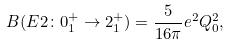Convert formula to latex. <formula><loc_0><loc_0><loc_500><loc_500>B ( E 2 \colon 0 _ { 1 } ^ { + } \rightarrow 2 _ { 1 } ^ { + } ) = \frac { 5 } { 1 6 \pi } e ^ { 2 } Q _ { 0 } ^ { 2 } ,</formula> 